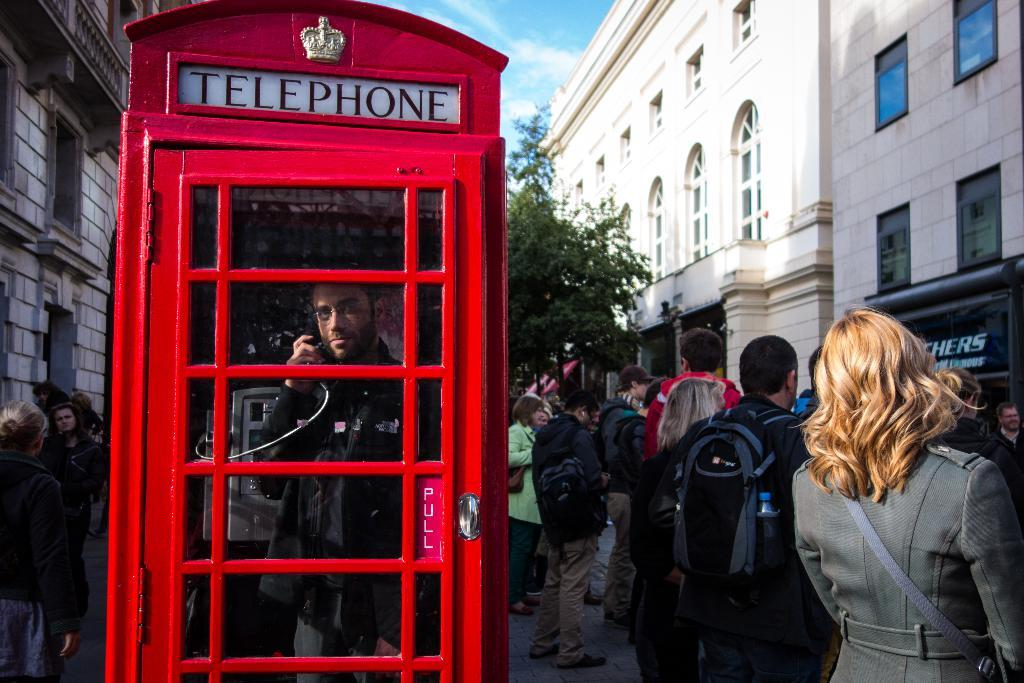<image>
Offer a succinct explanation of the picture presented. A tall red box is a telephone booth. 